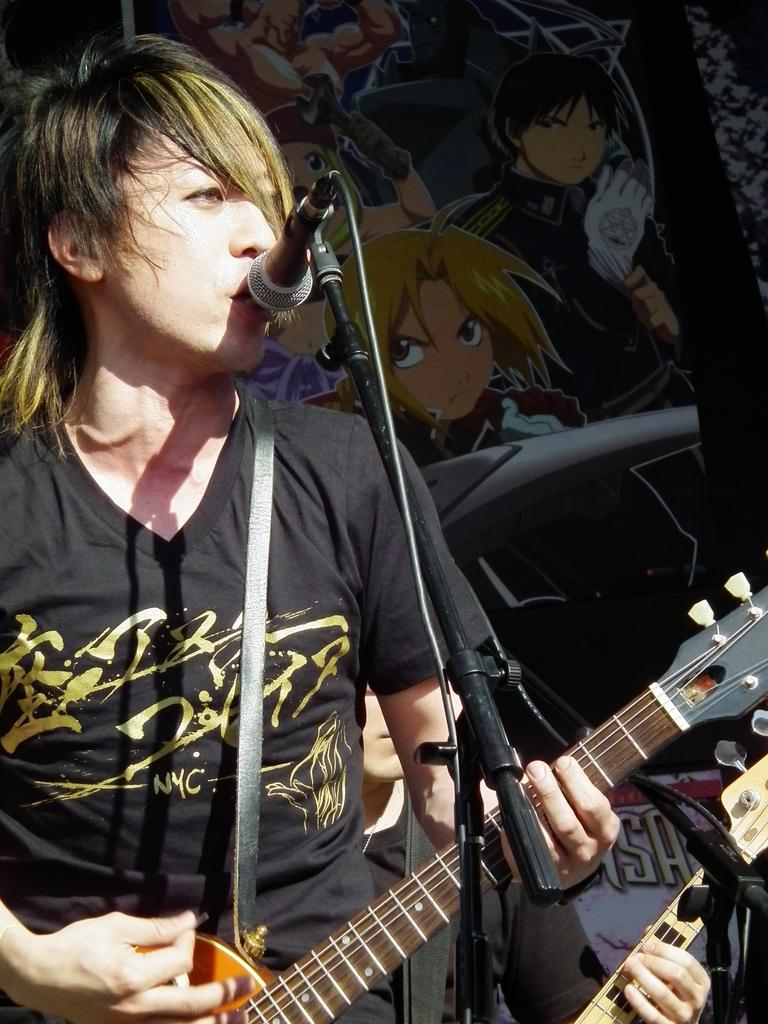What is the main subject of the image? There is a man in the image. What is the man doing in the image? The man is standing in the image. What object is the man holding in the image? The man is holding a guitar in the image. What other object can be seen in the image? There is a microphone in the image. What type of stamp is the man using to play the guitar in the image? There is no stamp present in the image, and the man is not using any stamp to play the guitar. 